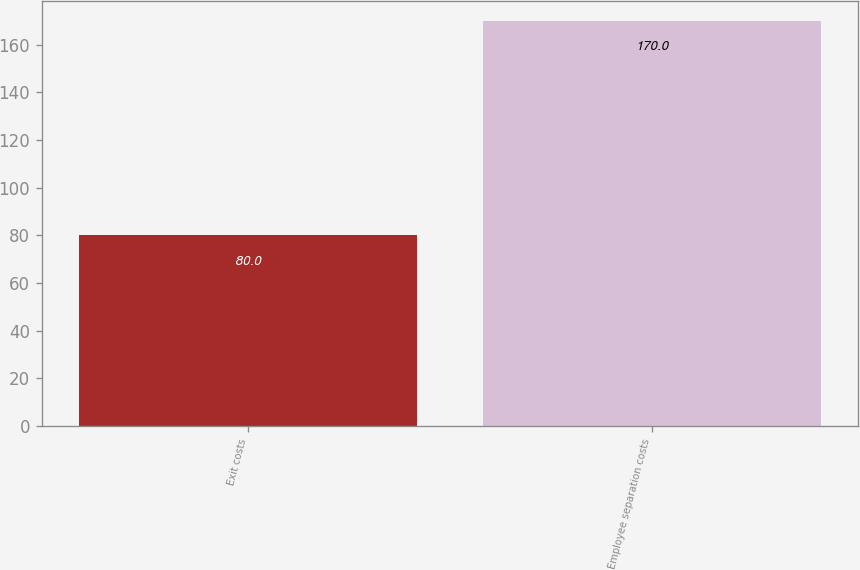<chart> <loc_0><loc_0><loc_500><loc_500><bar_chart><fcel>Exit costs<fcel>Employee separation costs<nl><fcel>80<fcel>170<nl></chart> 